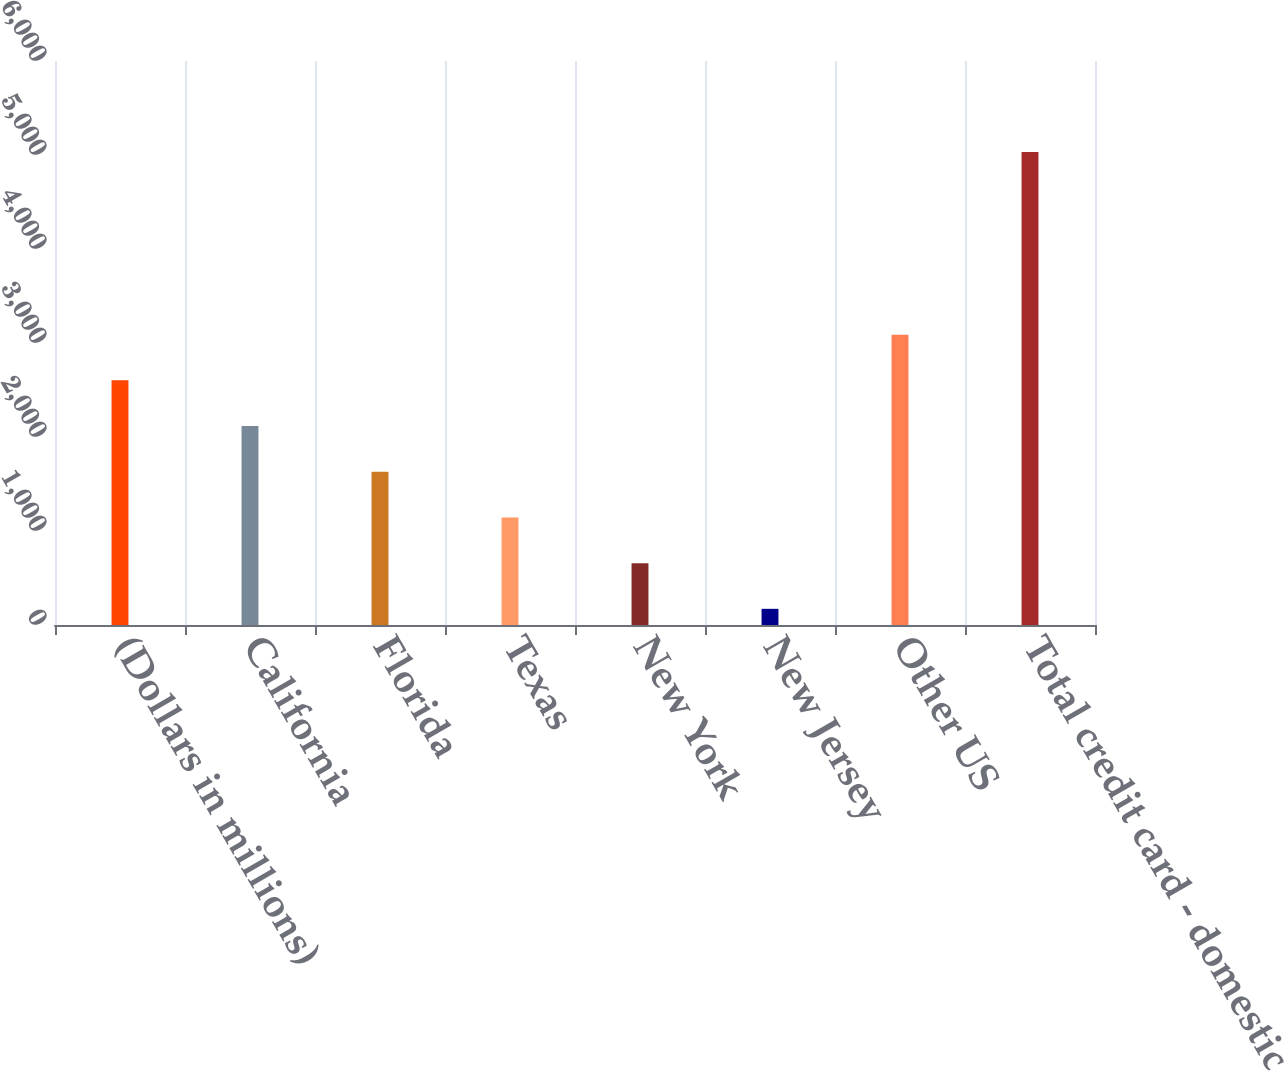<chart> <loc_0><loc_0><loc_500><loc_500><bar_chart><fcel>(Dollars in millions)<fcel>California<fcel>Florida<fcel>Texas<fcel>New York<fcel>New Jersey<fcel>Other US<fcel>Total credit card - domestic<nl><fcel>2602.5<fcel>2116.4<fcel>1630.3<fcel>1144.2<fcel>658.1<fcel>172<fcel>3088.6<fcel>5033<nl></chart> 